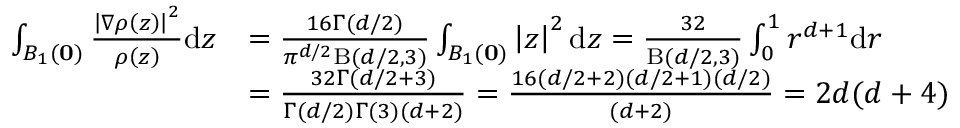<formula> <loc_0><loc_0><loc_500><loc_500>\begin{array} { r l } { \int _ { B _ { 1 } ( 0 ) } \frac { \left | \nabla \rho \left ( z \right ) \right | ^ { 2 } } { \rho \left ( z \right ) } d z } & { = \frac { 1 6 \Gamma ( d / 2 ) } { \pi ^ { d / 2 } B ( d / 2 , 3 ) } \int _ { B _ { 1 } ( 0 ) } \left | z \right | ^ { 2 } d z = \frac { 3 2 } { B ( d / 2 , 3 ) } \int _ { 0 } ^ { 1 } r ^ { d + 1 } d r } \\ & { = \frac { 3 2 \Gamma ( d / 2 + 3 ) } { \Gamma ( d / 2 ) \Gamma ( 3 ) ( d + 2 ) } = \frac { 1 6 ( d / 2 + 2 ) ( d / 2 + 1 ) ( d / 2 ) } { ( d + 2 ) } = 2 d ( d + 4 ) } \end{array}</formula> 